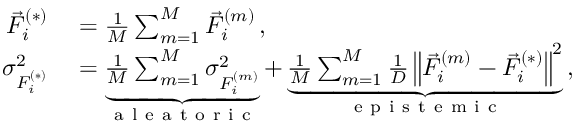<formula> <loc_0><loc_0><loc_500><loc_500>\begin{array} { r l } { \vec { F } _ { i } ^ { ( * ) } } & = \frac { 1 } { M } \sum _ { m = 1 } ^ { M } \vec { F } _ { i } ^ { ( m ) } \, , } \\ { \sigma _ { F _ { i } ^ { ( * ) } } ^ { 2 } } & = \underbrace { \frac { 1 } { M } \sum _ { m = 1 } ^ { M } \sigma _ { F _ { i } ^ { ( m ) } } ^ { 2 } } _ { a l e a t o r i c } + \underbrace { \frac { 1 } { M } \sum _ { m = 1 } ^ { M } \frac { 1 } { D } \left \| \vec { F } _ { i } ^ { ( m ) } - \vec { F } _ { i } ^ { ( * ) } \right \| ^ { 2 } } _ { e p i s t e m i c } \, , } \end{array}</formula> 